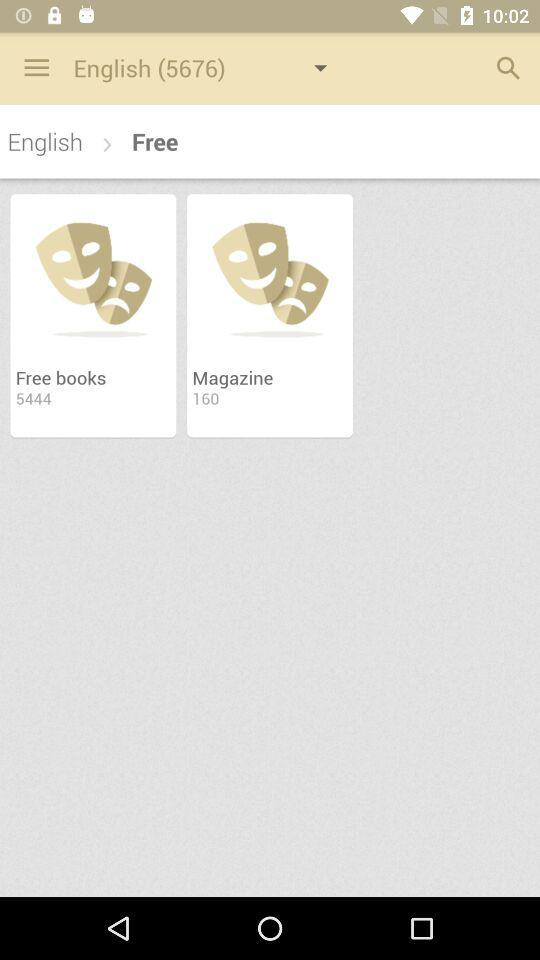How many magazines are there? There are 160 magazines. 